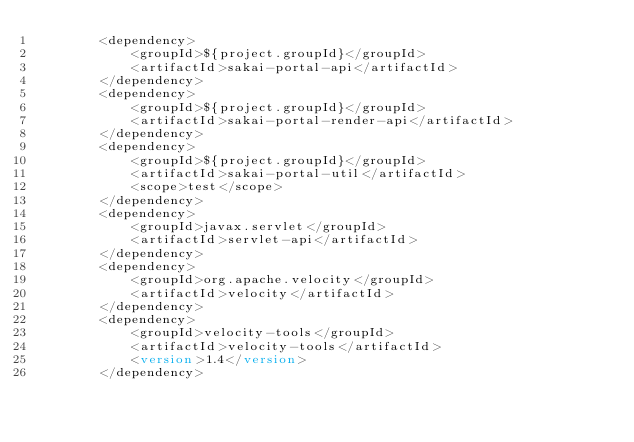Convert code to text. <code><loc_0><loc_0><loc_500><loc_500><_XML_>        <dependency>
            <groupId>${project.groupId}</groupId>
            <artifactId>sakai-portal-api</artifactId>
        </dependency>
        <dependency>
            <groupId>${project.groupId}</groupId>
            <artifactId>sakai-portal-render-api</artifactId>
        </dependency>
        <dependency>
            <groupId>${project.groupId}</groupId>
            <artifactId>sakai-portal-util</artifactId>
            <scope>test</scope>
        </dependency>
        <dependency>
            <groupId>javax.servlet</groupId>
            <artifactId>servlet-api</artifactId>
        </dependency>
        <dependency>
            <groupId>org.apache.velocity</groupId>
            <artifactId>velocity</artifactId>
        </dependency>
        <dependency>
            <groupId>velocity-tools</groupId>
            <artifactId>velocity-tools</artifactId>
            <version>1.4</version>
        </dependency></code> 